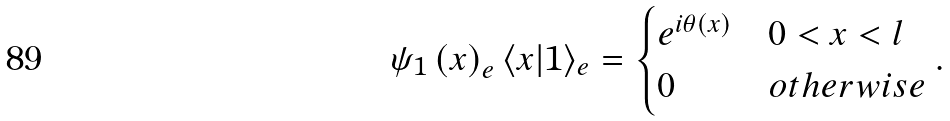<formula> <loc_0><loc_0><loc_500><loc_500>\psi _ { 1 } \left ( x \right ) _ { e } \langle x | 1 \rangle _ { e } = \begin{cases} e ^ { i \theta \left ( x \right ) } & 0 < x < l \\ 0 & o t h e r w i s e \end{cases} .</formula> 